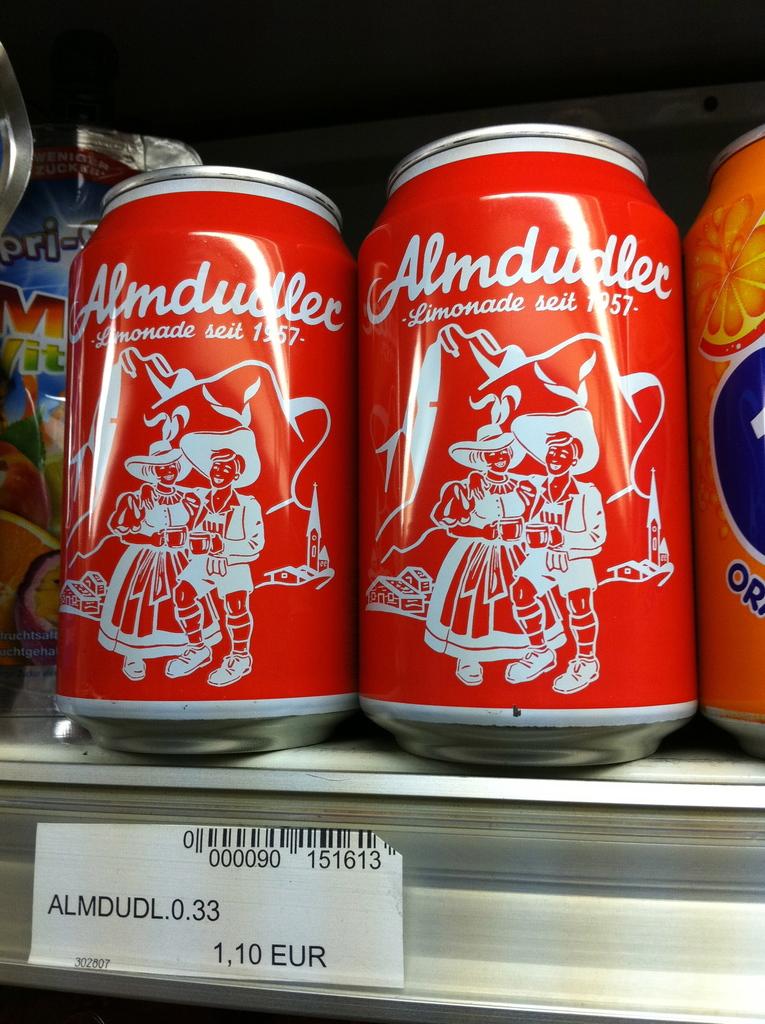What is the brand of drink?
Your response must be concise. Almdudler. 